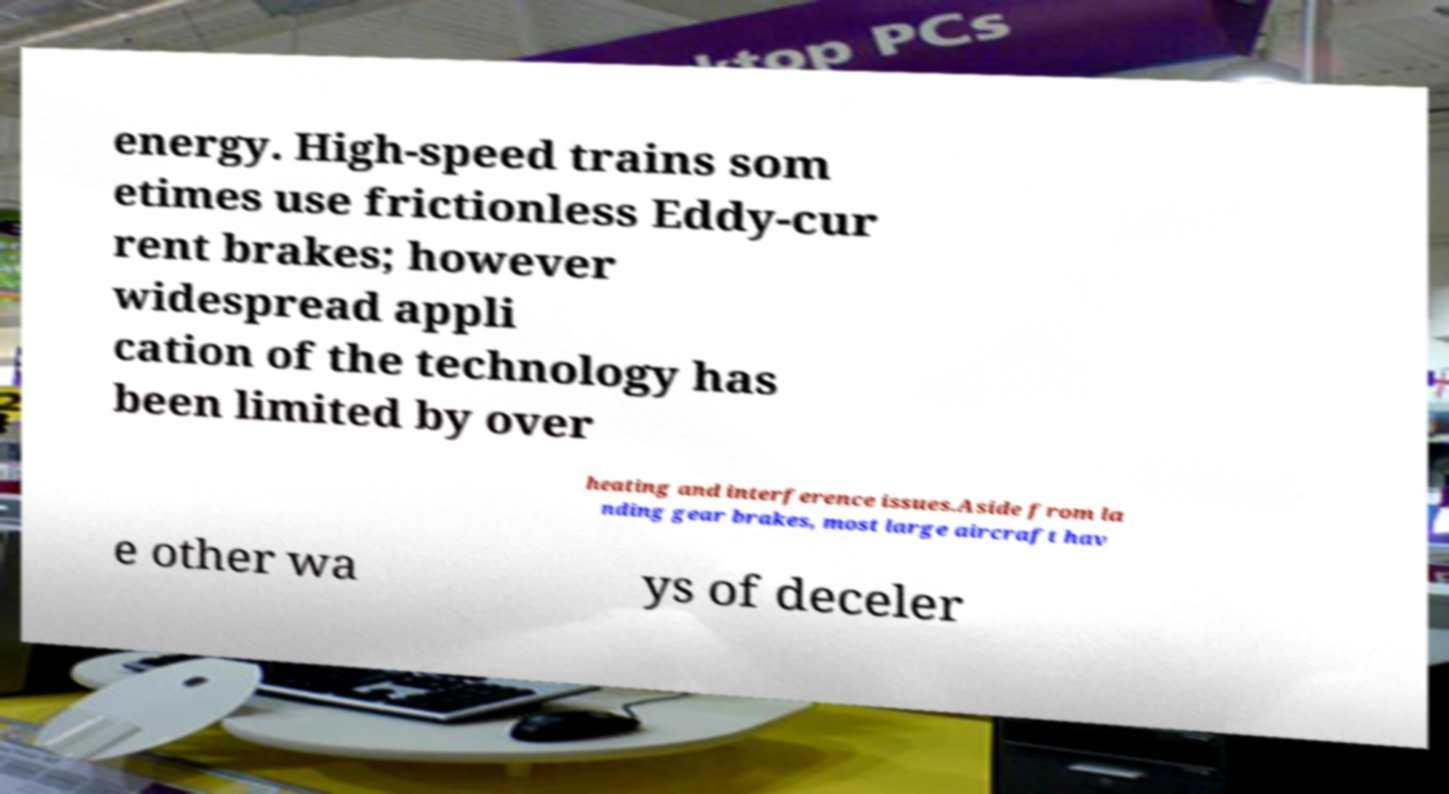Could you assist in decoding the text presented in this image and type it out clearly? energy. High-speed trains som etimes use frictionless Eddy-cur rent brakes; however widespread appli cation of the technology has been limited by over heating and interference issues.Aside from la nding gear brakes, most large aircraft hav e other wa ys of deceler 